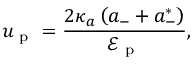Convert formula to latex. <formula><loc_0><loc_0><loc_500><loc_500>u _ { p } = \frac { 2 \kappa _ { a } \left ( a _ { - } + a _ { - } ^ { * } \right ) } { \mathcal { E } _ { p } } ,</formula> 